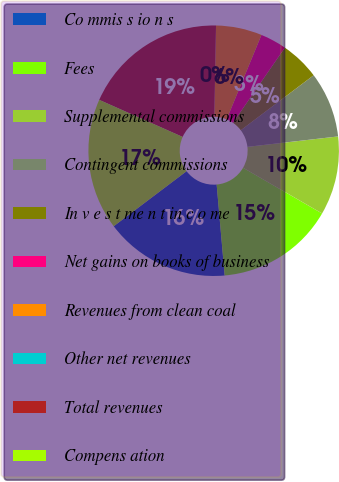Convert chart. <chart><loc_0><loc_0><loc_500><loc_500><pie_chart><fcel>Co mmis s io n s<fcel>Fees<fcel>Supplemental commissions<fcel>Contingent commissions<fcel>In v e s t me n t in c o me<fcel>Net gains on books of business<fcel>Revenues from clean coal<fcel>Other net revenues<fcel>Total revenues<fcel>Compens ation<nl><fcel>16.1%<fcel>15.25%<fcel>10.17%<fcel>8.47%<fcel>5.09%<fcel>3.39%<fcel>5.93%<fcel>0.0%<fcel>18.64%<fcel>16.95%<nl></chart> 